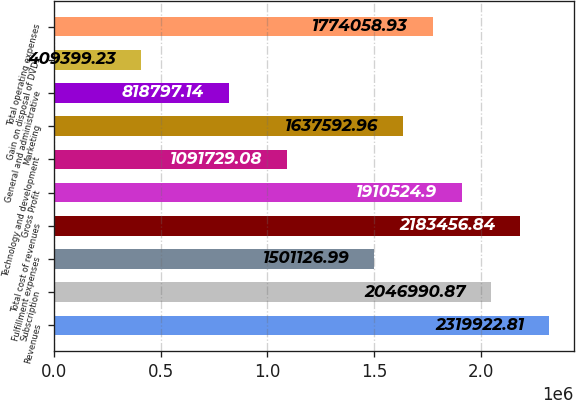<chart> <loc_0><loc_0><loc_500><loc_500><bar_chart><fcel>Revenues<fcel>Subscription<fcel>Fulfillment expenses<fcel>Total cost of revenues<fcel>Gross Profit<fcel>Technology and development<fcel>Marketing<fcel>General and administrative<fcel>Gain on disposal of DVDs<fcel>Total operating expenses<nl><fcel>2.31992e+06<fcel>2.04699e+06<fcel>1.50113e+06<fcel>2.18346e+06<fcel>1.91052e+06<fcel>1.09173e+06<fcel>1.63759e+06<fcel>818797<fcel>409399<fcel>1.77406e+06<nl></chart> 